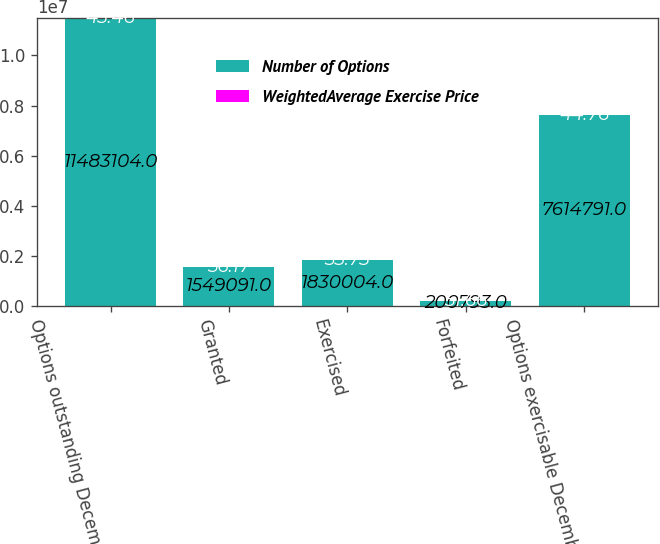Convert chart to OTSL. <chart><loc_0><loc_0><loc_500><loc_500><stacked_bar_chart><ecel><fcel>Options outstanding December<fcel>Granted<fcel>Exercised<fcel>Forfeited<fcel>Options exercisable December<nl><fcel>Number of Options<fcel>1.14831e+07<fcel>1.54909e+06<fcel>1.83e+06<fcel>200793<fcel>7.61479e+06<nl><fcel>WeightedAverage Exercise Price<fcel>45.46<fcel>56.17<fcel>35.73<fcel>51.66<fcel>44.76<nl></chart> 